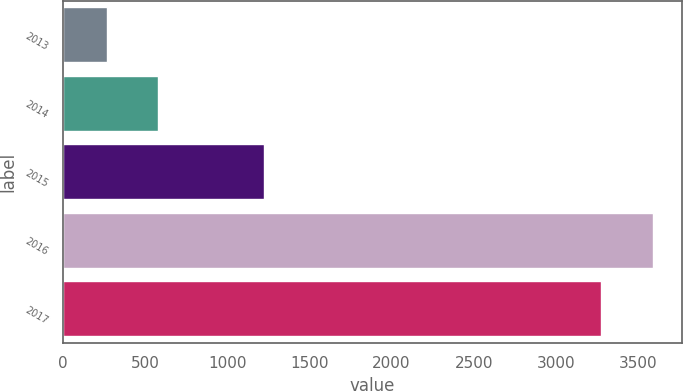Convert chart to OTSL. <chart><loc_0><loc_0><loc_500><loc_500><bar_chart><fcel>2013<fcel>2014<fcel>2015<fcel>2016<fcel>2017<nl><fcel>268<fcel>582.7<fcel>1223<fcel>3587.7<fcel>3273<nl></chart> 